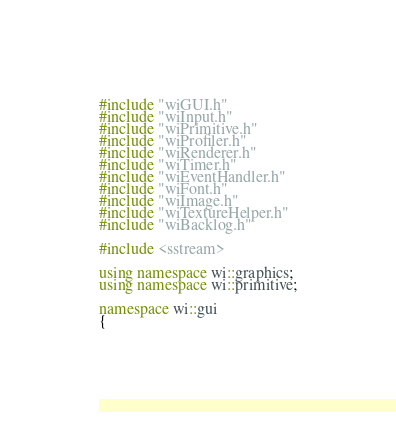<code> <loc_0><loc_0><loc_500><loc_500><_C++_>#include "wiGUI.h"
#include "wiInput.h"
#include "wiPrimitive.h"
#include "wiProfiler.h"
#include "wiRenderer.h"
#include "wiTimer.h"
#include "wiEventHandler.h"
#include "wiFont.h"
#include "wiImage.h"
#include "wiTextureHelper.h"
#include "wiBacklog.h"

#include <sstream>

using namespace wi::graphics;
using namespace wi::primitive;

namespace wi::gui
{</code> 